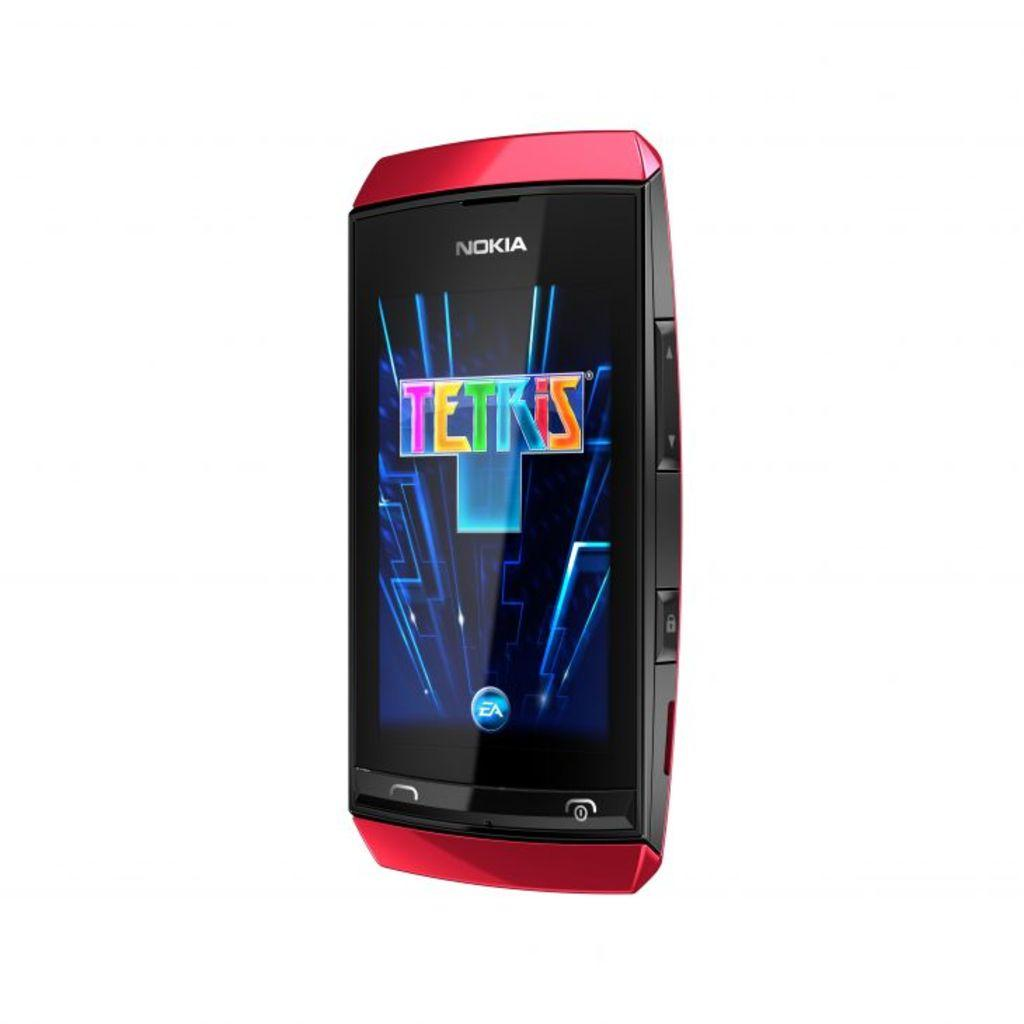What color is the background of the image? The background of the image is white. What is the main object in the middle of the image? There is a phone in the middle of the image. What can be seen on the top of the phone? The top of the phone has a colorful screen. What type of rice is being cooked in the background of the image? There is no rice present in the image; the background is white. Can you see any children playing in the field in the image? There is no field or children playing in the image; it features a phone with a colorful screen on a white background. 